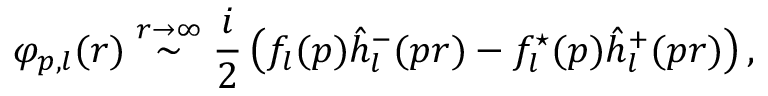Convert formula to latex. <formula><loc_0><loc_0><loc_500><loc_500>\varphi _ { p , l } ( r ) \stackrel { r \rightarrow \infty } { \sim } \frac { i } { 2 } \left ( f _ { l } ( p ) \hat { h } _ { l } ^ { - } ( p r ) - f _ { l } ^ { ^ { * } } ( p ) \hat { h } _ { l } ^ { + } ( p r ) \right ) ,</formula> 